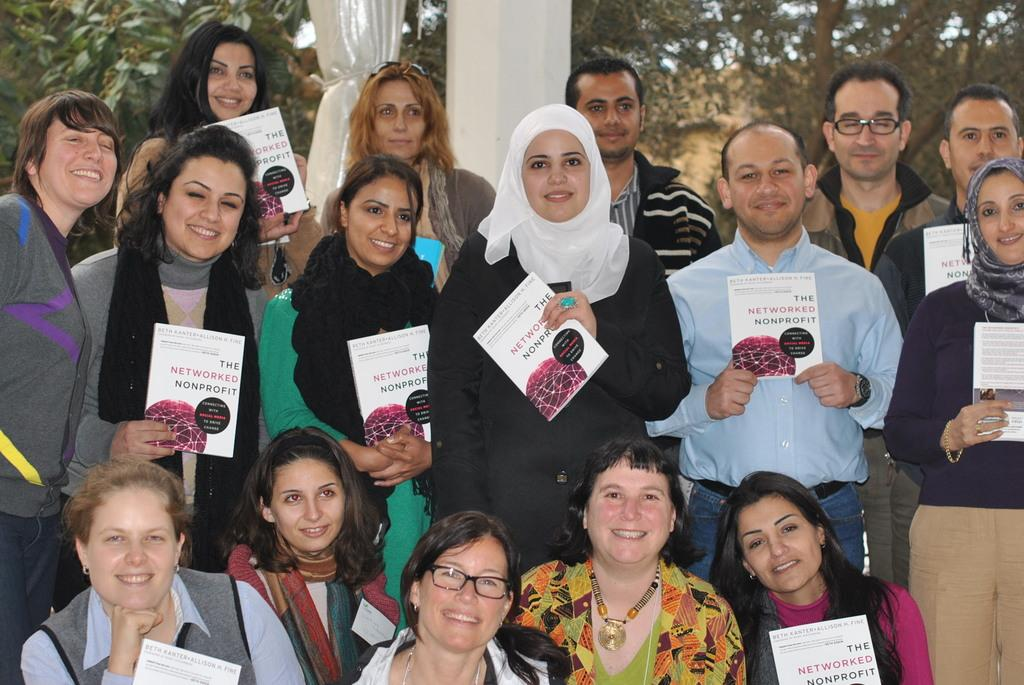What are the people in the foreground of the image holding? The people in the foreground of the image are holding pamphlets. What can be seen in the background of the image? There are trees, a curtain, a pillar, and the sky visible in the background of the image. Can you describe the vegetation in the image? The vegetation in the image consists of trees in the background. What type of sidewalk can be seen in the image? There is no sidewalk present in the image. How does the zipper on the curtain work in the image? There is no zipper on the curtain in the image; it is a solid piece of fabric. 